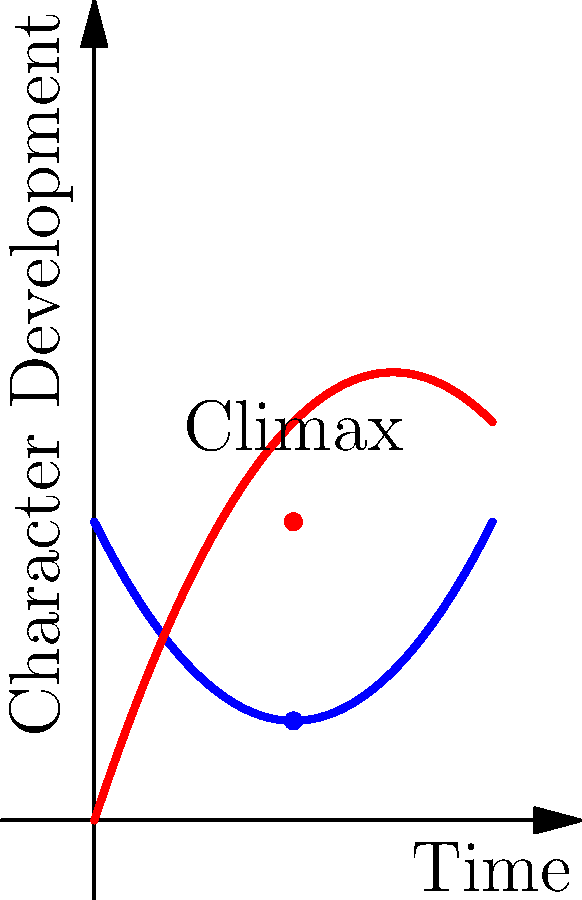In the context of Mongolian storytelling traditions, analyze the character arcs represented in this graph. Which character undergoes a more dynamic transformation, and how might this reflect themes often explored in contemporary Mongolian cinema? To answer this question, let's analyze the graph step-by-step:

1. The graph shows two character arcs: Character A (blue) and Character B (red).

2. Character A's arc:
   - Starts high on the y-axis (Character Development)
   - Decreases initially
   - Reaches its lowest point around the middle of the story
   - Gradually rises towards the end

3. Character B's arc:
   - Starts low on the y-axis
   - Rises steadily throughout the story
   - Reaches its peak at the climax point

4. Comparing the arcs:
   - Character B shows a more dramatic change from beginning to end
   - Character A's change is less pronounced and more cyclical

5. In the context of Mongolian storytelling and cinema:
   - Character B's arc aligns with themes of personal growth, overcoming adversity, and transformation
   - This reflects common themes in contemporary Mongolian cinema, such as the struggle between tradition and modernity, or the journey of self-discovery

6. The more dynamic transformation of Character B might represent:
   - The changing landscape of Mongolia (both literal and figurative)
   - The evolution of cultural identity in the face of globalization
   - The personal growth often depicted in coming-of-age stories, a genre explored by filmmakers like Lkhagvadulam Purev-Ochir

Therefore, Character B undergoes a more dynamic transformation, reflecting themes of change, growth, and adaptation often explored in contemporary Mongolian cinema.
Answer: Character B; reflects themes of transformation and growth in contemporary Mongolian cinema 